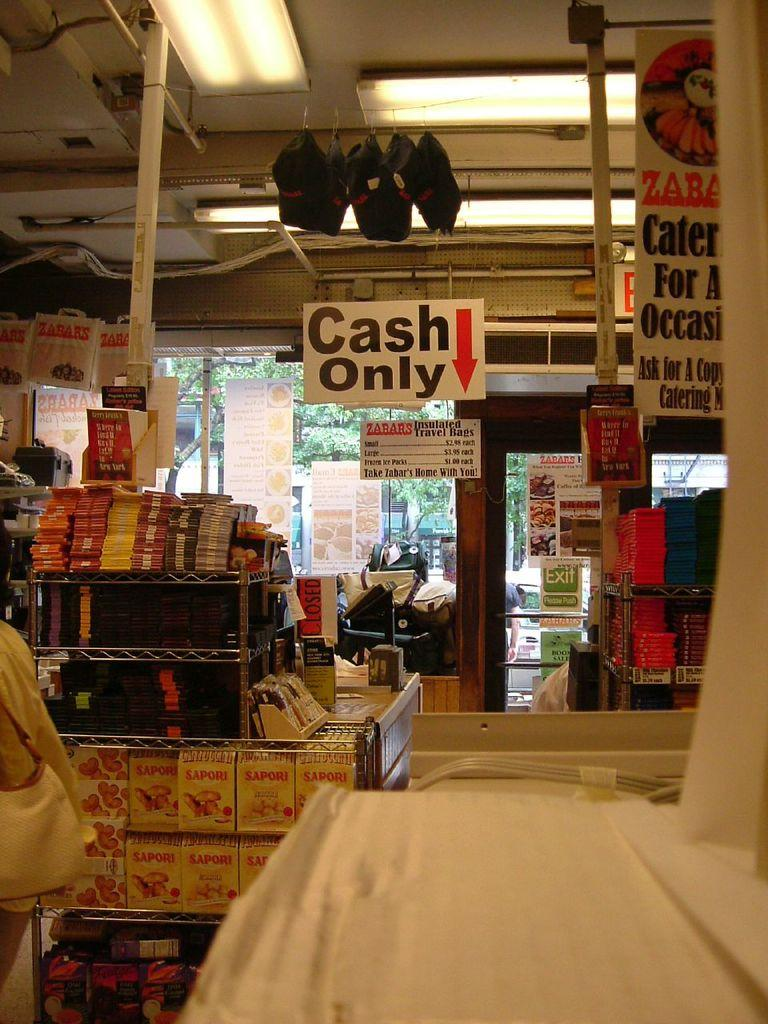<image>
Describe the image concisely. A sign that is hanging up and says Cash only on it, with a red arrow. 